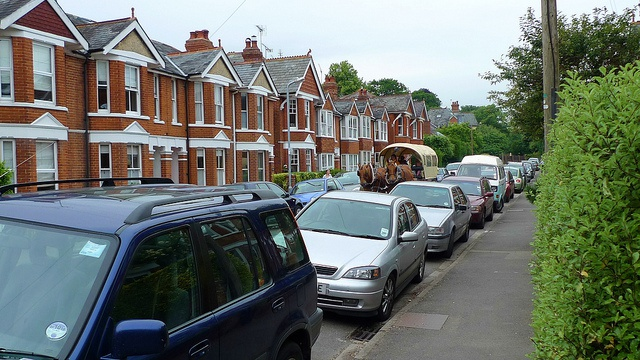Describe the objects in this image and their specific colors. I can see car in gray and black tones, car in gray, white, and black tones, car in gray, black, and lightgray tones, car in gray, black, and darkgray tones, and bus in gray, white, and darkgray tones in this image. 